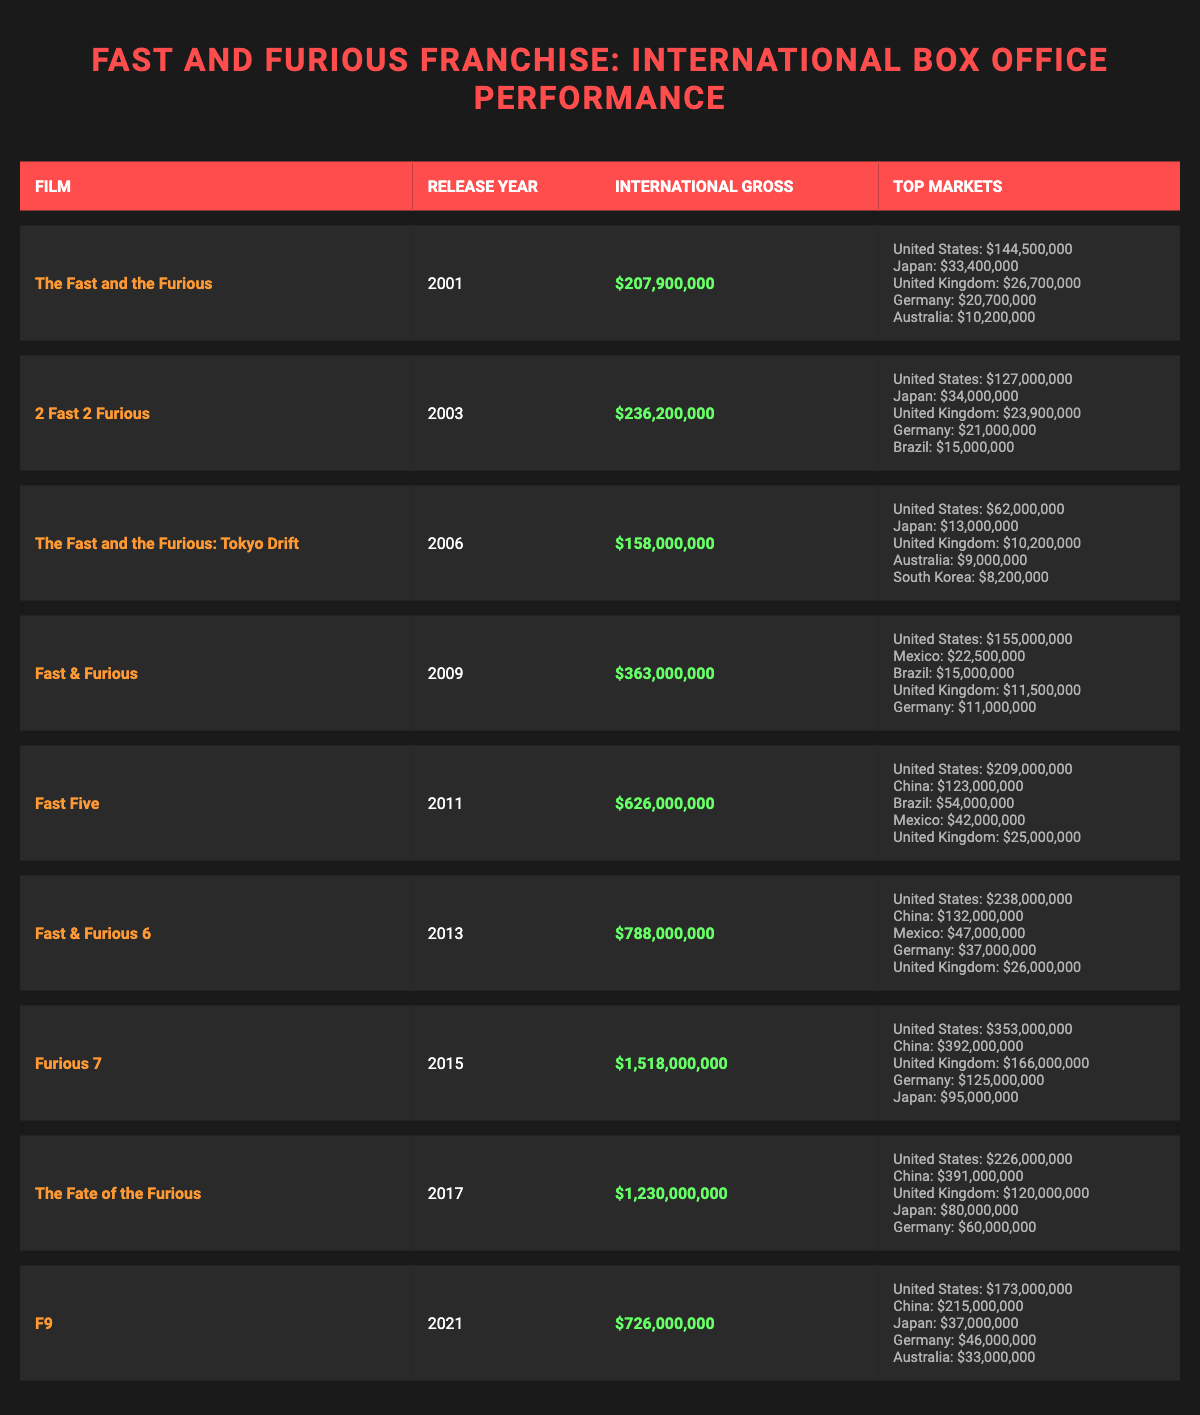What is the international gross of "Furious 7"? The table shows that "Furious 7" has an international gross of $1,518,000,000.
Answer: $1,518,000,000 Which film had the highest international gross? By comparing the international gross values in the table, "Furious 7" at $1,518,000,000 is the highest.
Answer: "Furious 7" What was the international gross of "Fast Five" and "Fast & Furious 6" combined? "Fast Five" has an international gross of $626,000,000, and "Fast & Furious 6" has $788,000,000. Adding these together gives $626,000,000 + $788,000,000 = $1,414,000,000.
Answer: $1,414,000,000 Did "The Fate of the Furious" gross more than "F9"? "The Fate of the Furious" grossed $1,230,000,000, while "F9" grossed $726,000,000. Since $1,230,000,000 is greater than $726,000,000, the statement is true.
Answer: Yes Which country was the top market for "Fast & Furious 6"? The table indicates that for "Fast & Furious 6", the top market was the United States with a gross of $238,000,000.
Answer: United States How much did "F9" earn in China? The table shows that "F9" earned $215,000,000 in China.
Answer: $215,000,000 Which film experienced the largest increase in international gross compared to the previous film in the franchise? The gross of "Furious 7" is $1,518,000,000 and "Fast & Furious 6" is $788,000,000. The increase is $1,518,000,000 - $788,000,000 = $730,000,000. By checking each film, this increase is the largest seen.
Answer: "Furious 7" Did "2 Fast 2 Furious" earn more than $240,000,000 internationally? Looking at the international gross for "2 Fast 2 Furious," which is $236,200,000, it did not reach $240,000,000. Therefore, this statement is false.
Answer: No What are the top three markets for "The Fast and the Furious"? According to the table, the top three markets are: United States ($144,500,000), Japan ($33,400,000), and the United Kingdom ($26,700,000).
Answer: United States, Japan, United Kingdom 